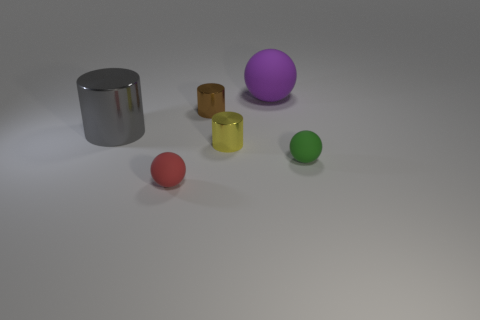Add 3 cyan matte cylinders. How many objects exist? 9 Add 3 green rubber objects. How many green rubber objects exist? 4 Subtract 0 green cylinders. How many objects are left? 6 Subtract all big gray metallic cylinders. Subtract all big gray shiny things. How many objects are left? 4 Add 6 red objects. How many red objects are left? 7 